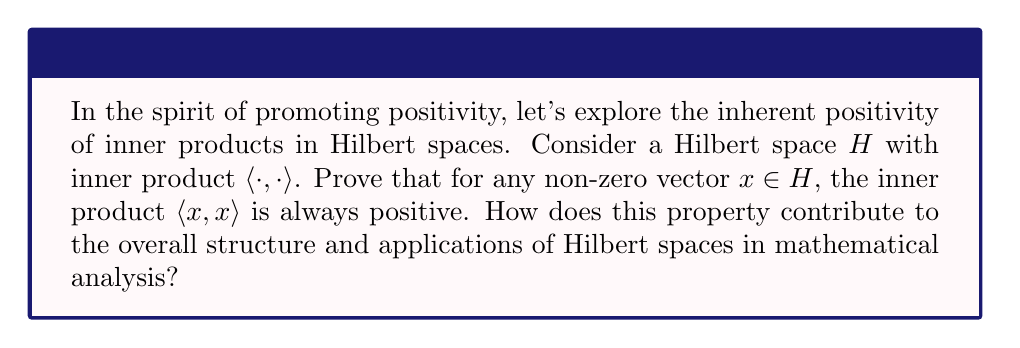Can you solve this math problem? Let's prove the positivity of inner products in Hilbert spaces step by step:

1) First, recall the definition of an inner product. For any vectors $x, y \in H$, the inner product $\langle x, y \rangle$ satisfies:
   a) Conjugate symmetry: $\langle x, y \rangle = \overline{\langle y, x \rangle}$
   b) Linearity in the first argument
   c) Positive definiteness: $\langle x, x \rangle \geq 0$, and $\langle x, x \rangle = 0$ if and only if $x = 0$

2) Now, let's focus on proving that $\langle x, x \rangle > 0$ for any non-zero vector $x \in H$:
   
   From the positive definiteness property, we know that $\langle x, x \rangle \geq 0$ for all $x \in H$.

3) Suppose $x \neq 0$. Then, by the positive definiteness property, we must have $\langle x, x \rangle > 0$.

4) This is because if $\langle x, x \rangle = 0$, then $x$ would have to be the zero vector, which contradicts our assumption that $x \neq 0$.

5) Therefore, for any non-zero vector $x \in H$, $\langle x, x \rangle > 0$.

This property contributes significantly to the structure and applications of Hilbert spaces:

a) It allows for the definition of a norm: $\|x\| = \sqrt{\langle x, x \rangle}$
b) It ensures that Hilbert spaces are always normed vector spaces
c) It enables the use of geometric intuitions from Euclidean spaces in more abstract settings
d) It plays a crucial role in many applications, such as quantum mechanics and signal processing, where the inner product represents physical quantities that must be positive

By understanding and appreciating this fundamental property, we can see how mathematics inherently contains elements of positivity, mirroring our efforts to create positive content in the online space.
Answer: $\langle x, x \rangle > 0$ for all non-zero $x \in H$ 